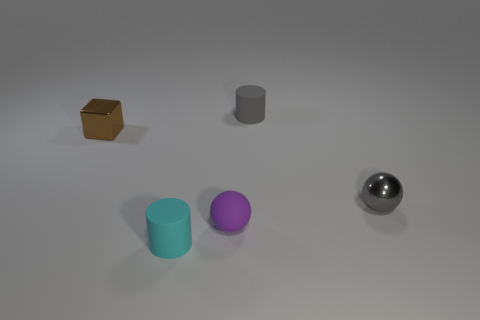Add 4 small cylinders. How many objects exist? 9 Subtract all tiny metallic objects. Subtract all tiny green metal cubes. How many objects are left? 3 Add 1 brown cubes. How many brown cubes are left? 2 Add 5 small blue spheres. How many small blue spheres exist? 5 Subtract 0 yellow balls. How many objects are left? 5 Subtract all cubes. How many objects are left? 4 